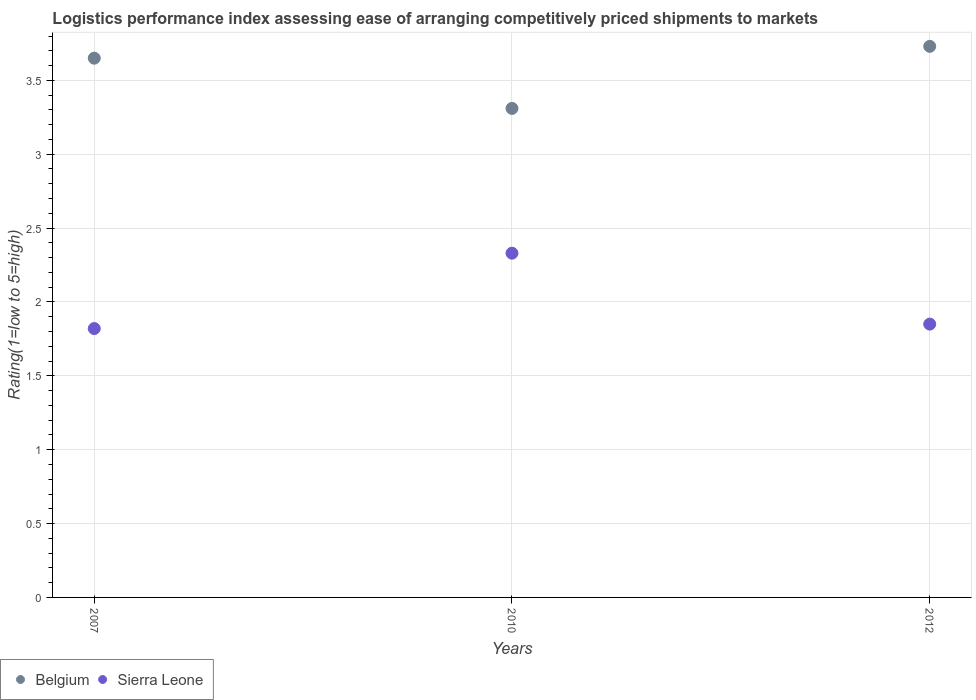How many different coloured dotlines are there?
Give a very brief answer. 2. Is the number of dotlines equal to the number of legend labels?
Keep it short and to the point. Yes. What is the Logistic performance index in Sierra Leone in 2010?
Provide a succinct answer. 2.33. Across all years, what is the maximum Logistic performance index in Belgium?
Keep it short and to the point. 3.73. Across all years, what is the minimum Logistic performance index in Belgium?
Your answer should be very brief. 3.31. In which year was the Logistic performance index in Sierra Leone maximum?
Offer a very short reply. 2010. What is the total Logistic performance index in Sierra Leone in the graph?
Provide a succinct answer. 6. What is the difference between the Logistic performance index in Belgium in 2007 and that in 2012?
Give a very brief answer. -0.08. In how many years, is the Logistic performance index in Sierra Leone greater than 1.2?
Provide a succinct answer. 3. What is the ratio of the Logistic performance index in Belgium in 2010 to that in 2012?
Ensure brevity in your answer.  0.89. Is the Logistic performance index in Belgium in 2010 less than that in 2012?
Provide a short and direct response. Yes. What is the difference between the highest and the second highest Logistic performance index in Sierra Leone?
Make the answer very short. 0.48. What is the difference between the highest and the lowest Logistic performance index in Sierra Leone?
Give a very brief answer. 0.51. Is the Logistic performance index in Belgium strictly greater than the Logistic performance index in Sierra Leone over the years?
Give a very brief answer. Yes. Is the Logistic performance index in Sierra Leone strictly less than the Logistic performance index in Belgium over the years?
Make the answer very short. Yes. Are the values on the major ticks of Y-axis written in scientific E-notation?
Offer a terse response. No. Does the graph contain any zero values?
Offer a very short reply. No. What is the title of the graph?
Give a very brief answer. Logistics performance index assessing ease of arranging competitively priced shipments to markets. What is the label or title of the X-axis?
Keep it short and to the point. Years. What is the label or title of the Y-axis?
Give a very brief answer. Rating(1=low to 5=high). What is the Rating(1=low to 5=high) in Belgium in 2007?
Offer a very short reply. 3.65. What is the Rating(1=low to 5=high) of Sierra Leone in 2007?
Offer a terse response. 1.82. What is the Rating(1=low to 5=high) in Belgium in 2010?
Provide a succinct answer. 3.31. What is the Rating(1=low to 5=high) of Sierra Leone in 2010?
Provide a short and direct response. 2.33. What is the Rating(1=low to 5=high) in Belgium in 2012?
Your answer should be very brief. 3.73. What is the Rating(1=low to 5=high) in Sierra Leone in 2012?
Give a very brief answer. 1.85. Across all years, what is the maximum Rating(1=low to 5=high) in Belgium?
Your response must be concise. 3.73. Across all years, what is the maximum Rating(1=low to 5=high) in Sierra Leone?
Offer a terse response. 2.33. Across all years, what is the minimum Rating(1=low to 5=high) of Belgium?
Offer a terse response. 3.31. Across all years, what is the minimum Rating(1=low to 5=high) in Sierra Leone?
Give a very brief answer. 1.82. What is the total Rating(1=low to 5=high) of Belgium in the graph?
Offer a terse response. 10.69. What is the difference between the Rating(1=low to 5=high) of Belgium in 2007 and that in 2010?
Offer a very short reply. 0.34. What is the difference between the Rating(1=low to 5=high) of Sierra Leone in 2007 and that in 2010?
Make the answer very short. -0.51. What is the difference between the Rating(1=low to 5=high) in Belgium in 2007 and that in 2012?
Your answer should be compact. -0.08. What is the difference between the Rating(1=low to 5=high) in Sierra Leone in 2007 and that in 2012?
Provide a short and direct response. -0.03. What is the difference between the Rating(1=low to 5=high) of Belgium in 2010 and that in 2012?
Offer a very short reply. -0.42. What is the difference between the Rating(1=low to 5=high) of Sierra Leone in 2010 and that in 2012?
Make the answer very short. 0.48. What is the difference between the Rating(1=low to 5=high) in Belgium in 2007 and the Rating(1=low to 5=high) in Sierra Leone in 2010?
Your response must be concise. 1.32. What is the difference between the Rating(1=low to 5=high) in Belgium in 2007 and the Rating(1=low to 5=high) in Sierra Leone in 2012?
Provide a succinct answer. 1.8. What is the difference between the Rating(1=low to 5=high) in Belgium in 2010 and the Rating(1=low to 5=high) in Sierra Leone in 2012?
Make the answer very short. 1.46. What is the average Rating(1=low to 5=high) of Belgium per year?
Give a very brief answer. 3.56. What is the average Rating(1=low to 5=high) in Sierra Leone per year?
Make the answer very short. 2. In the year 2007, what is the difference between the Rating(1=low to 5=high) of Belgium and Rating(1=low to 5=high) of Sierra Leone?
Your answer should be very brief. 1.83. In the year 2012, what is the difference between the Rating(1=low to 5=high) of Belgium and Rating(1=low to 5=high) of Sierra Leone?
Give a very brief answer. 1.88. What is the ratio of the Rating(1=low to 5=high) in Belgium in 2007 to that in 2010?
Make the answer very short. 1.1. What is the ratio of the Rating(1=low to 5=high) of Sierra Leone in 2007 to that in 2010?
Offer a terse response. 0.78. What is the ratio of the Rating(1=low to 5=high) in Belgium in 2007 to that in 2012?
Give a very brief answer. 0.98. What is the ratio of the Rating(1=low to 5=high) of Sierra Leone in 2007 to that in 2012?
Keep it short and to the point. 0.98. What is the ratio of the Rating(1=low to 5=high) in Belgium in 2010 to that in 2012?
Make the answer very short. 0.89. What is the ratio of the Rating(1=low to 5=high) of Sierra Leone in 2010 to that in 2012?
Your response must be concise. 1.26. What is the difference between the highest and the second highest Rating(1=low to 5=high) of Sierra Leone?
Provide a short and direct response. 0.48. What is the difference between the highest and the lowest Rating(1=low to 5=high) in Belgium?
Your answer should be very brief. 0.42. What is the difference between the highest and the lowest Rating(1=low to 5=high) in Sierra Leone?
Give a very brief answer. 0.51. 